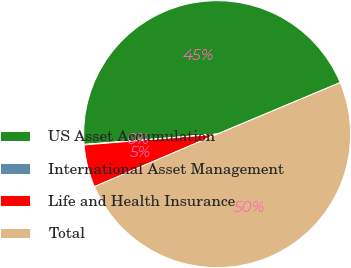Convert chart. <chart><loc_0><loc_0><loc_500><loc_500><pie_chart><fcel>US Asset Accumulation<fcel>International Asset Management<fcel>Life and Health Insurance<fcel>Total<nl><fcel>44.91%<fcel>0.07%<fcel>5.14%<fcel>49.88%<nl></chart> 